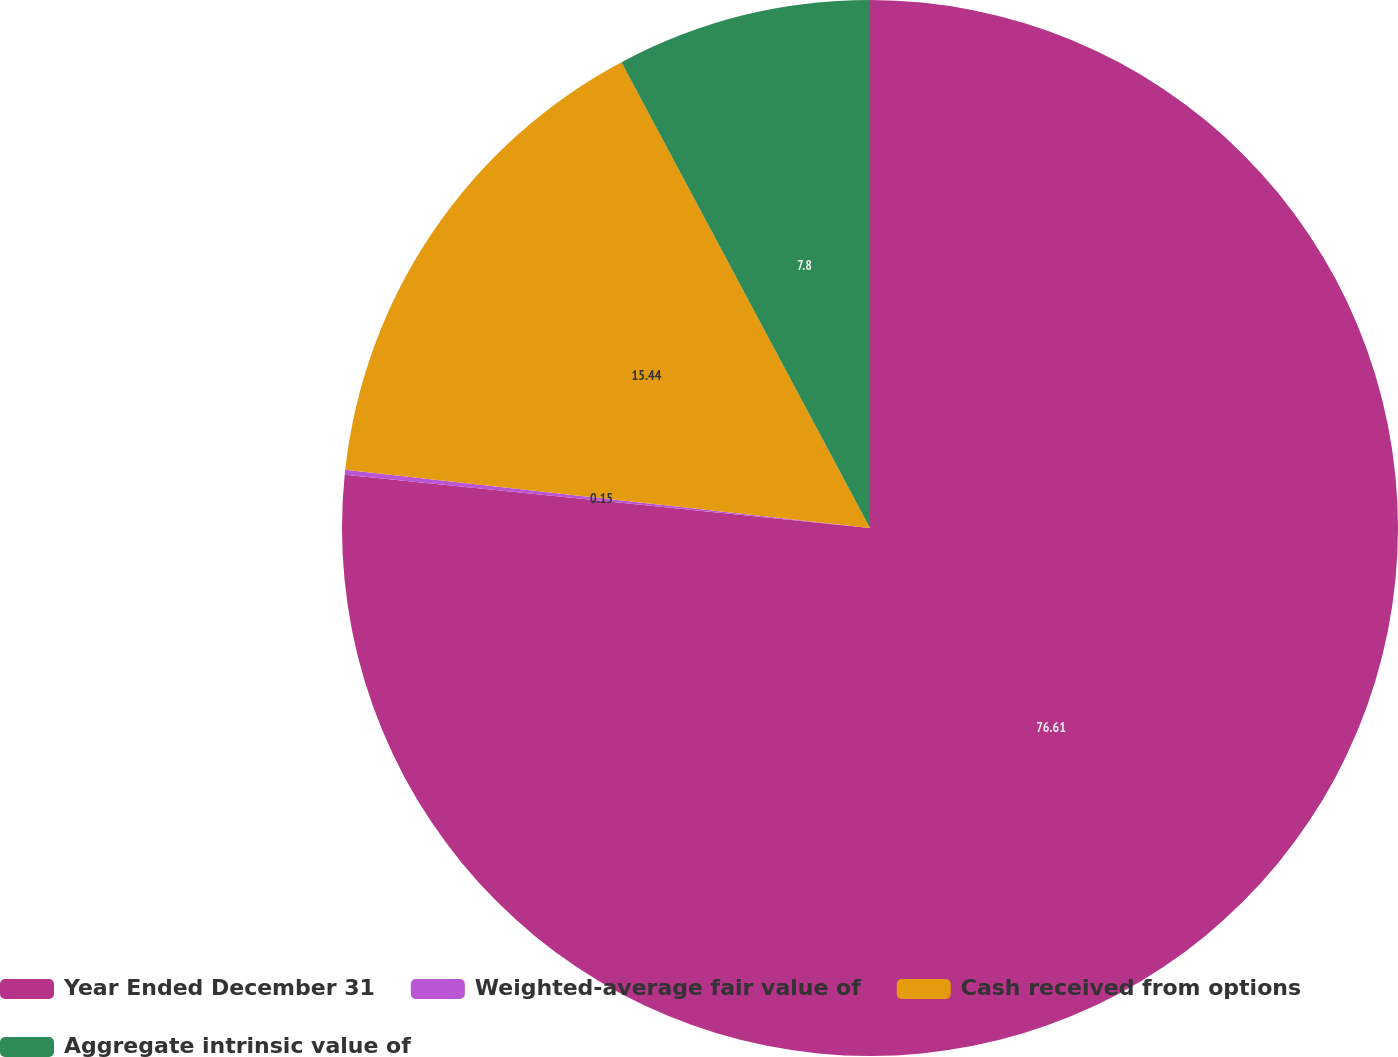Convert chart to OTSL. <chart><loc_0><loc_0><loc_500><loc_500><pie_chart><fcel>Year Ended December 31<fcel>Weighted-average fair value of<fcel>Cash received from options<fcel>Aggregate intrinsic value of<nl><fcel>76.6%<fcel>0.15%<fcel>15.44%<fcel>7.8%<nl></chart> 